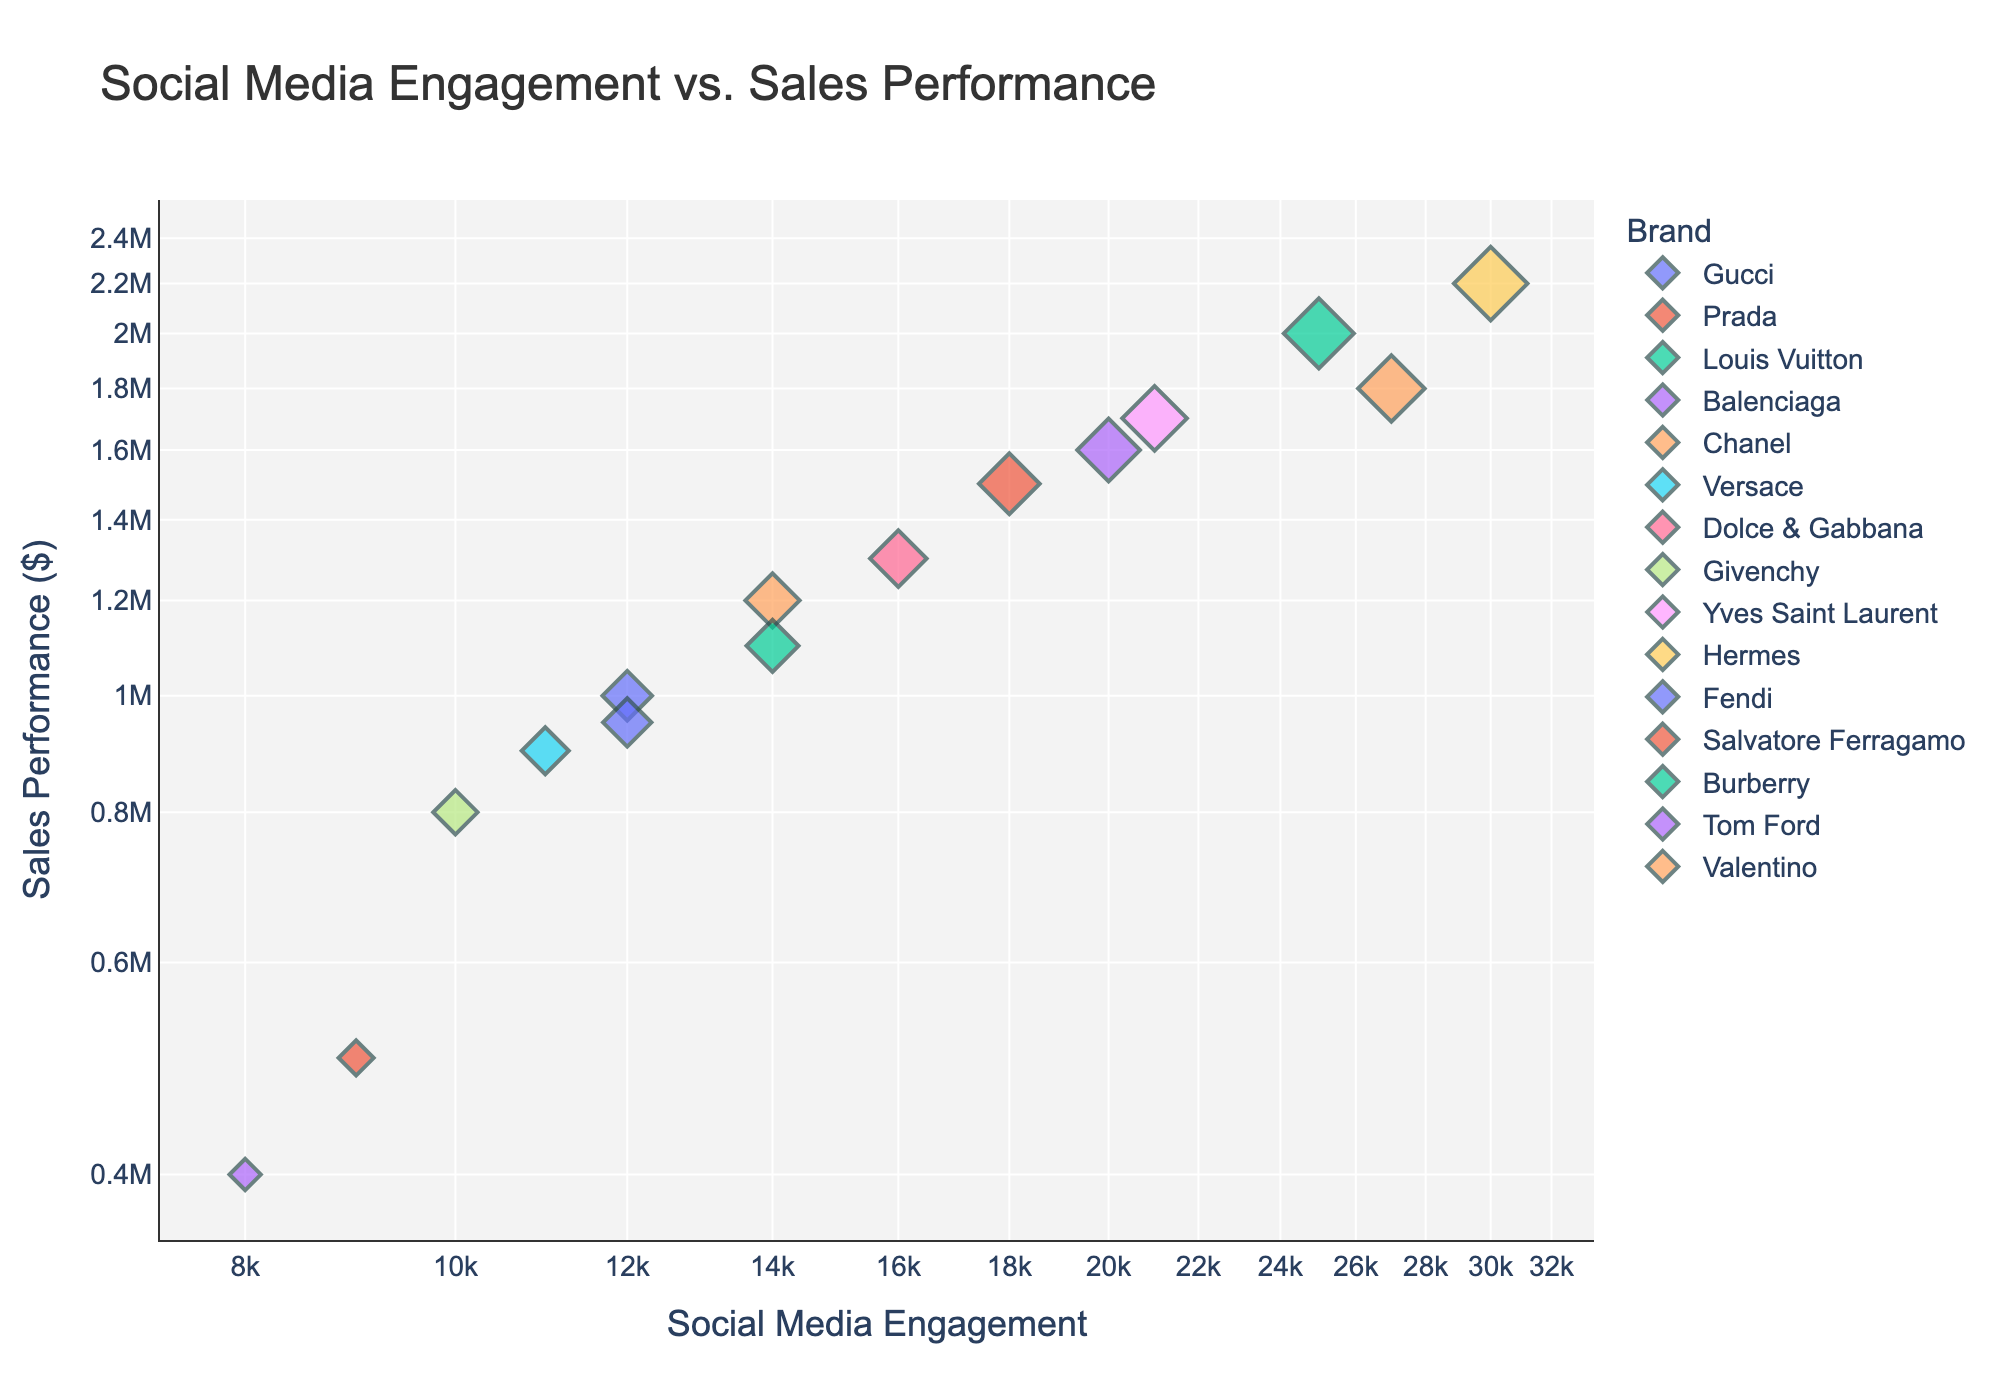How many brands are displayed in the scatter plot? Count the number of unique brands on the scatter plot by referring to the legend.
Answer: 15 Which collection has the highest social media engagement? Identify the data point on the x-axis with the highest value, refer to the hover information or legend to find the corresponding collection.
Answer: Hermes, Fall2022 What's the title of the scatter plot? Read the title displayed at the top of the scatter plot.
Answer: Social Media Engagement vs. Sales Performance Which brand shows the lowest sales performance? Look for the data point with the lowest value on the y-axis and refer to the hover information or legend for the brand.
Answer: Balenciaga What is the relationship between Gucci's Social Media Engagement and Sales Performance? Locate Gucci on the scatter plot, check its position on the log-scaled x and y-axes for Social Media Engagement and Sales Performance.
Answer: 12000 Social Media Engagement and $1,000,000 Sales Performance Does Hermes' engagement level significantly deviate from other brands? Compare Hermes' Social Media Engagement value on the x-axis to other brands' values to see if there is a significant difference.
Answer: Yes, it is significantly higher Which collection lies closest to the median Sales Performance? Arrange all the Sales Performance values in ascending order and locate the middle value, then find which brand's data point is closest to this value on the plot.
Answer: Givenchy, Spring2023 Are there any brands with the same Social Media Engagement level? Look at the x-axis to spot any brands that share the same engagement level value.
Answer: Yes, Gucci and Fendi Which two brands have the most similar performance in both metrics? Find the two data points closest on both axes.
Answer: Yves Saint Laurent and Tom Ford What's the highest sales performance among the shown collections? Check the data point on the y-axis with the highest value and cross-check with the legend for the collection.
Answer: Hermes, Fall2022 